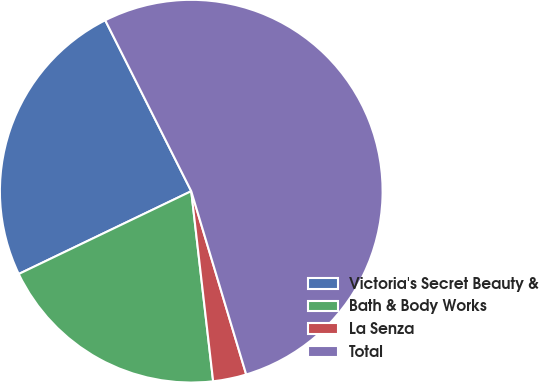Convert chart. <chart><loc_0><loc_0><loc_500><loc_500><pie_chart><fcel>Victoria's Secret Beauty &<fcel>Bath & Body Works<fcel>La Senza<fcel>Total<nl><fcel>24.7%<fcel>19.7%<fcel>2.81%<fcel>52.78%<nl></chart> 